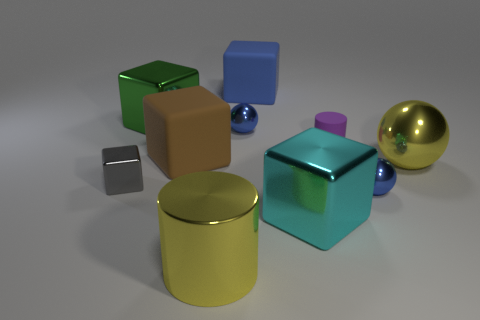Subtract all blue balls. How many were subtracted if there are1blue balls left? 1 Subtract all big cyan cubes. How many cubes are left? 4 Subtract all blue cubes. How many cubes are left? 4 Subtract all purple blocks. Subtract all blue balls. How many blocks are left? 5 Subtract all cylinders. How many objects are left? 8 Subtract 0 yellow blocks. How many objects are left? 10 Subtract all small cyan matte objects. Subtract all yellow shiny things. How many objects are left? 8 Add 5 large brown things. How many large brown things are left? 6 Add 4 large green blocks. How many large green blocks exist? 5 